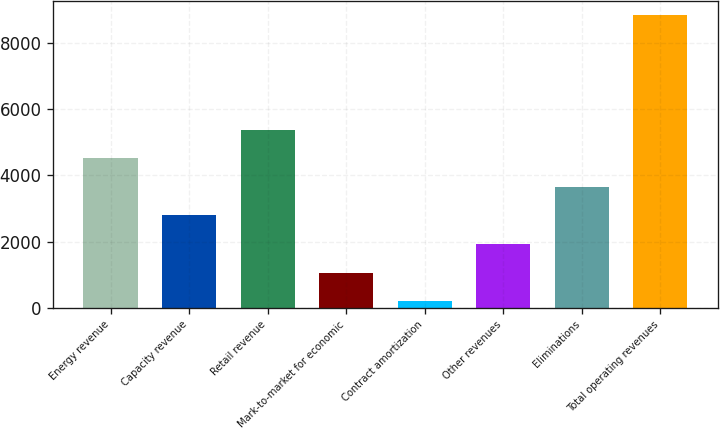Convert chart to OTSL. <chart><loc_0><loc_0><loc_500><loc_500><bar_chart><fcel>Energy revenue<fcel>Capacity revenue<fcel>Retail revenue<fcel>Mark-to-market for economic<fcel>Contract amortization<fcel>Other revenues<fcel>Eliminations<fcel>Total operating revenues<nl><fcel>4522<fcel>2791.2<fcel>5387.4<fcel>1060.4<fcel>195<fcel>1925.8<fcel>3656.6<fcel>8849<nl></chart> 